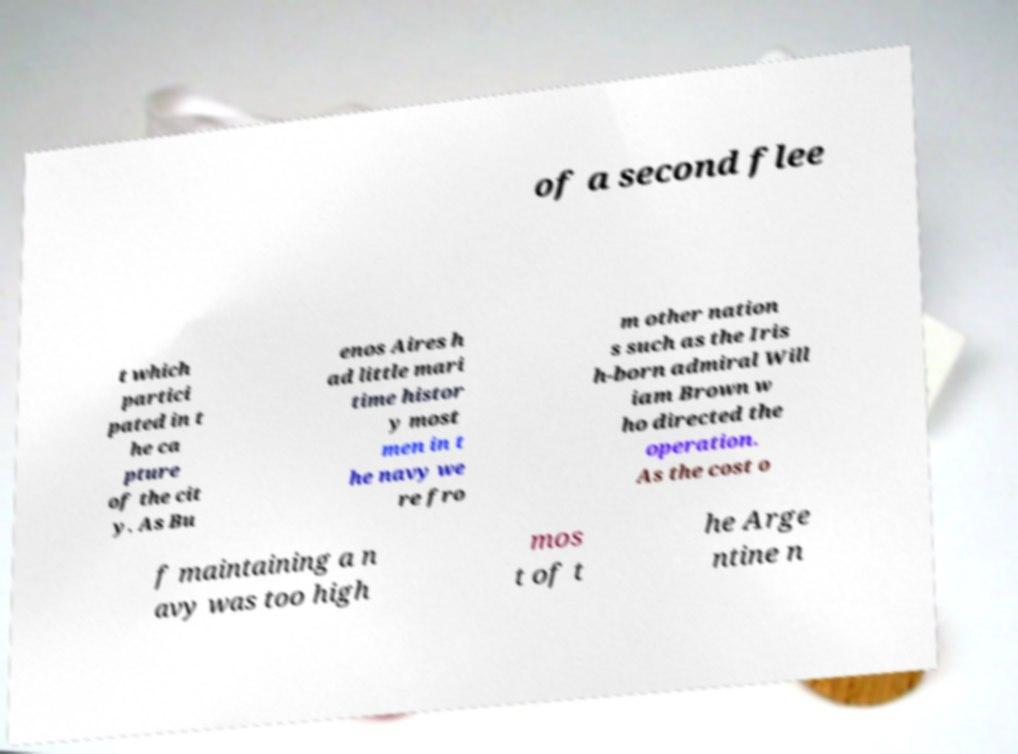Please read and relay the text visible in this image. What does it say? of a second flee t which partici pated in t he ca pture of the cit y. As Bu enos Aires h ad little mari time histor y most men in t he navy we re fro m other nation s such as the Iris h-born admiral Will iam Brown w ho directed the operation. As the cost o f maintaining a n avy was too high mos t of t he Arge ntine n 